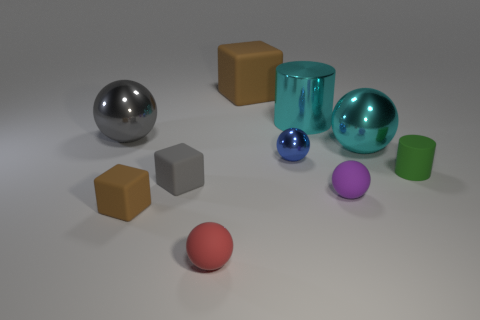Subtract all blue spheres. How many spheres are left? 4 Subtract all gray shiny spheres. How many spheres are left? 4 Subtract all yellow spheres. Subtract all gray cylinders. How many spheres are left? 5 Subtract all cylinders. How many objects are left? 8 Subtract all cyan metallic things. Subtract all green rubber cylinders. How many objects are left? 7 Add 4 small rubber spheres. How many small rubber spheres are left? 6 Add 9 large blue metallic blocks. How many large blue metallic blocks exist? 9 Subtract 0 brown cylinders. How many objects are left? 10 